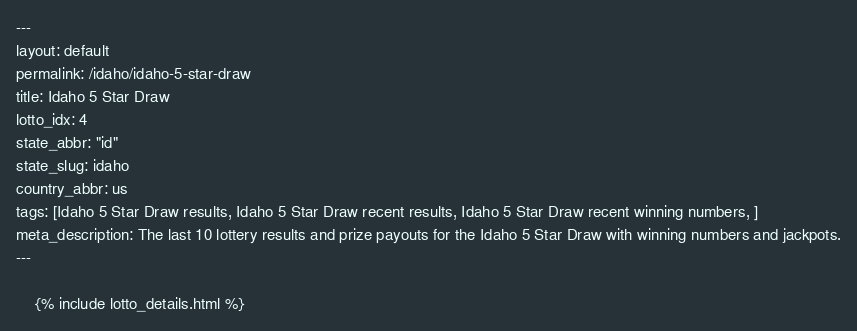<code> <loc_0><loc_0><loc_500><loc_500><_HTML_>---
layout: default
permalink: /idaho/idaho-5-star-draw
title: Idaho 5 Star Draw
lotto_idx: 4
state_abbr: "id"
state_slug: idaho
country_abbr: us
tags: [Idaho 5 Star Draw results, Idaho 5 Star Draw recent results, Idaho 5 Star Draw recent winning numbers, ]
meta_description: The last 10 lottery results and prize payouts for the Idaho 5 Star Draw with winning numbers and jackpots.
---

    {% include lotto_details.html %}</code> 